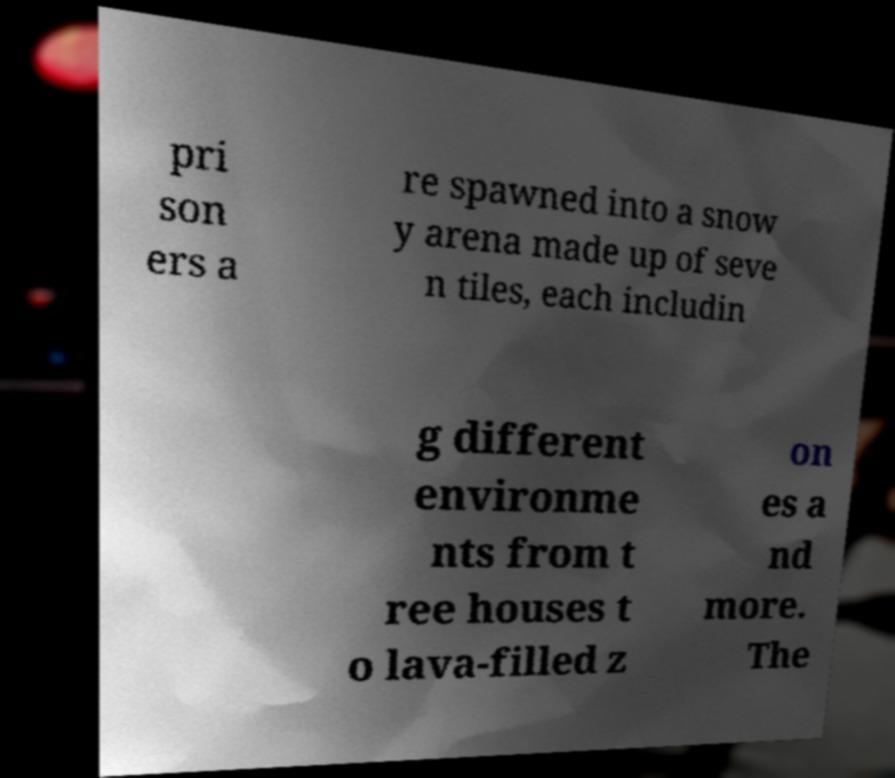Could you extract and type out the text from this image? pri son ers a re spawned into a snow y arena made up of seve n tiles, each includin g different environme nts from t ree houses t o lava-filled z on es a nd more. The 